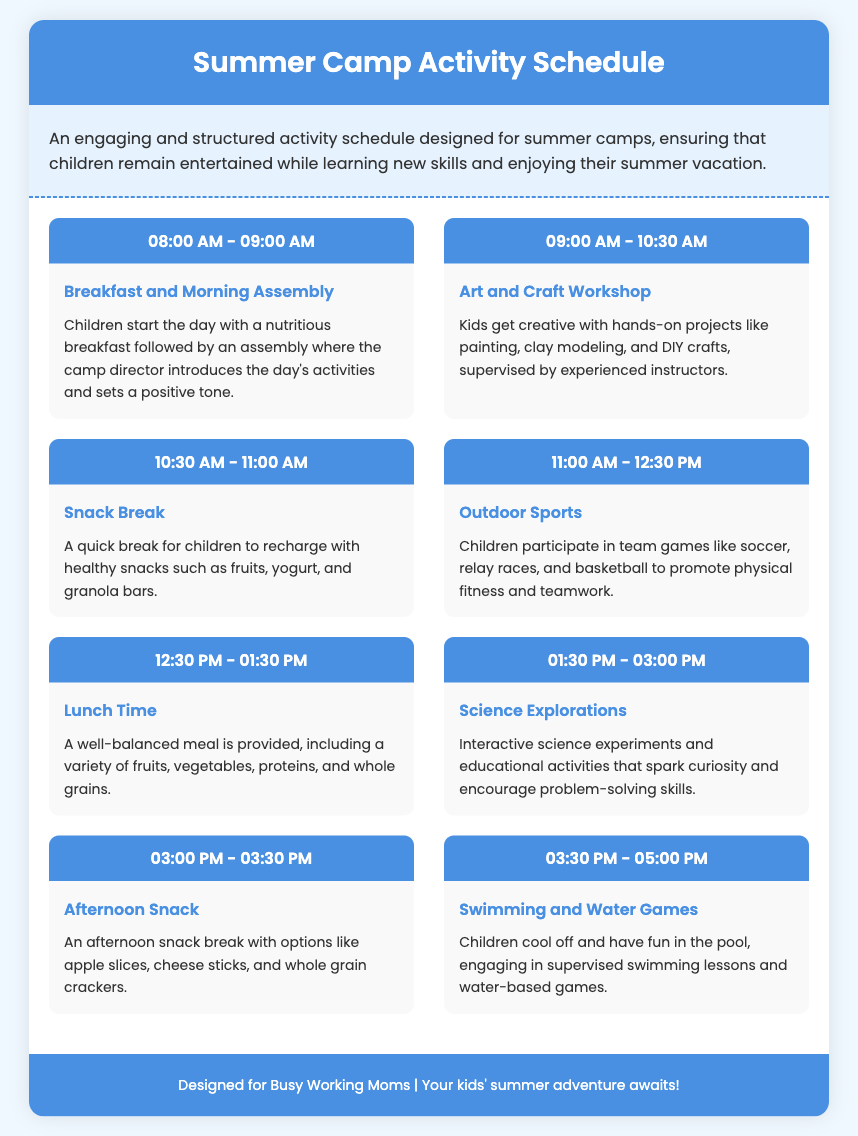What is the first activity of the day? The first activity is Breakfast and Morning Assembly, where children start the day with a nutritious breakfast followed by an assembly.
Answer: Breakfast and Morning Assembly What time does the Art and Craft Workshop start? The Art and Craft Workshop starts at 09:00 AM.
Answer: 09:00 AM How long is the Outdoor Sports activity? The Outdoor Sports activity is scheduled for 1 hour and 30 minutes, from 11:00 AM to 12:30 PM.
Answer: 1 hour and 30 minutes What type of meals are provided during lunch? Lunch Time provides a well-balanced meal including a variety of fruits, vegetables, proteins, and whole grains.
Answer: Well-balanced meal How many snack breaks are included in the schedule? There are two designated snack breaks included in the schedule: one in the morning and one in the afternoon.
Answer: Two What is the main focus of the Science Explorations activity? The main focus of the Science Explorations activity is interactive science experiments and educational activities.
Answer: Science experiments What is the activity following Lunch Time? The activity following Lunch Time is Science Explorations.
Answer: Science Explorations What color is the header of the document? The header of the document has a background color of #4a90e2 (blue).
Answer: Blue 